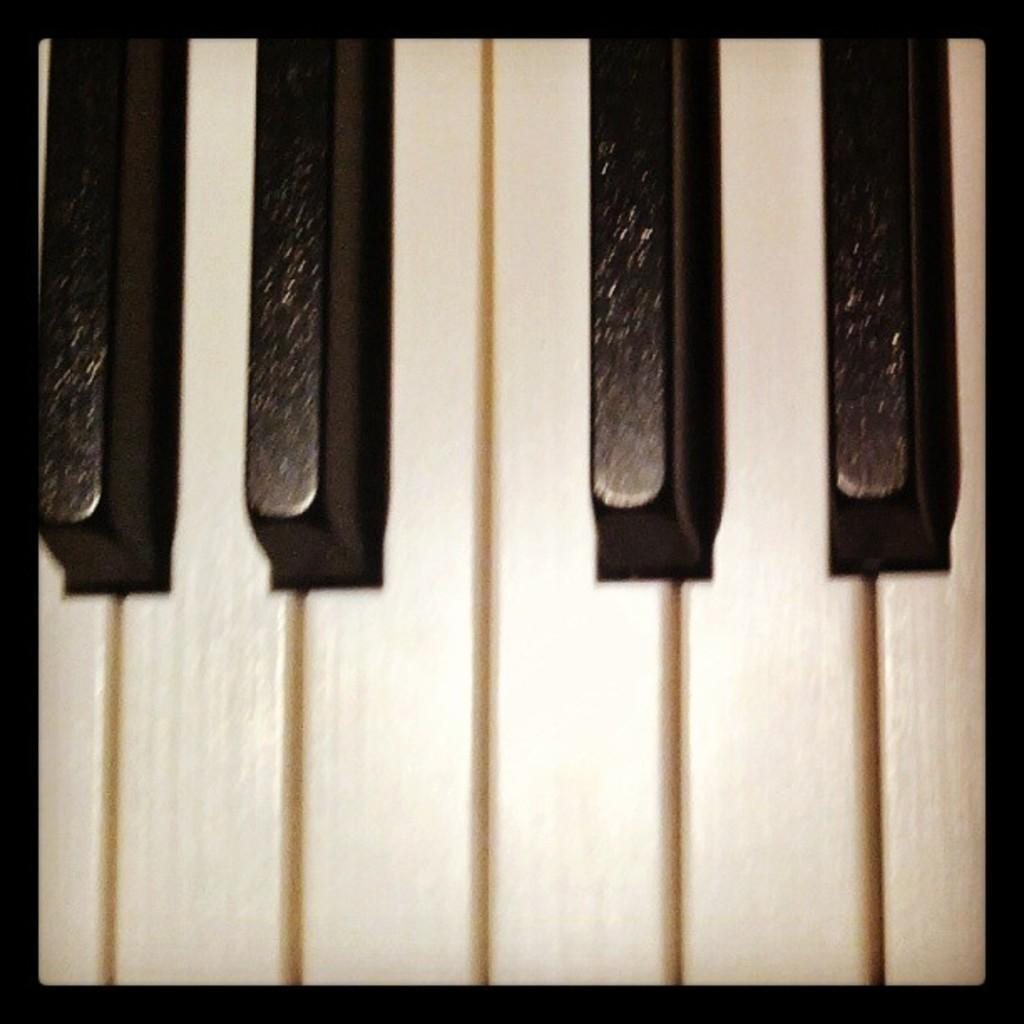What type of instrument is present in the image? There is a musical keyboard in the image. What might someone be doing with the musical keyboard? Someone might be playing the musical keyboard or practicing their skills. Can you describe the design of the musical keyboard? The design of the musical keyboard is not visible in the image, but it is a common instrument with keys that produce different notes when pressed. What type of birthday celebration is depicted in the image? There is no birthday celebration present in the image; it only features a musical keyboard. 